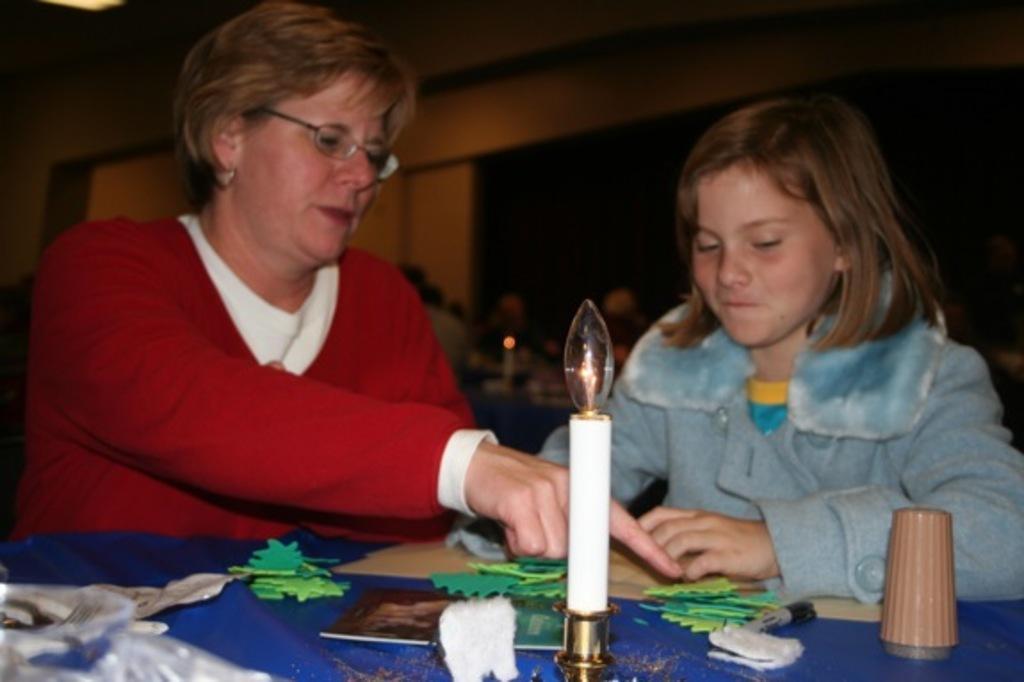How would you summarize this image in a sentence or two? In this image there is a woman sitting in chair , a girl sitting in chair, and in table there are glass, candle,bulb, book , color papers, paper and in back ground there are group of people and a wall. 